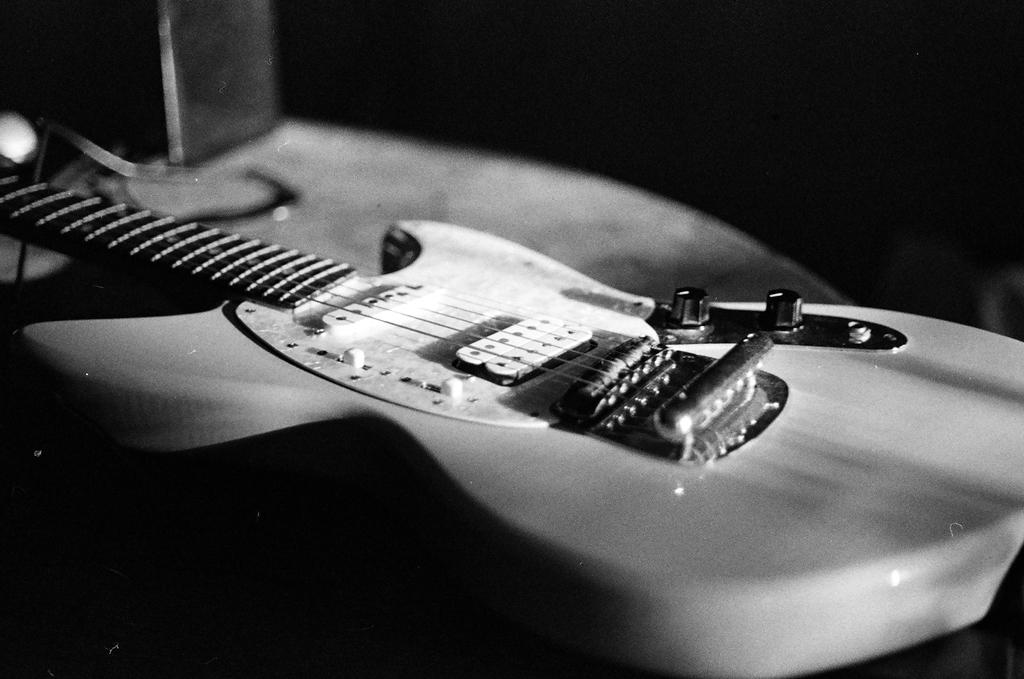What is the color scheme of the image? The image is black and white. What object is the main focus of the image? There is a guitar in the image. How would you describe the background of the image? The background of the image is dark. How many bikes are parked next to the guitar in the image? There are no bikes present in the image; it only features a guitar. What type of pear is being played on the guitar in the image? There is no pear present in the image, and the guitar is not being played. 